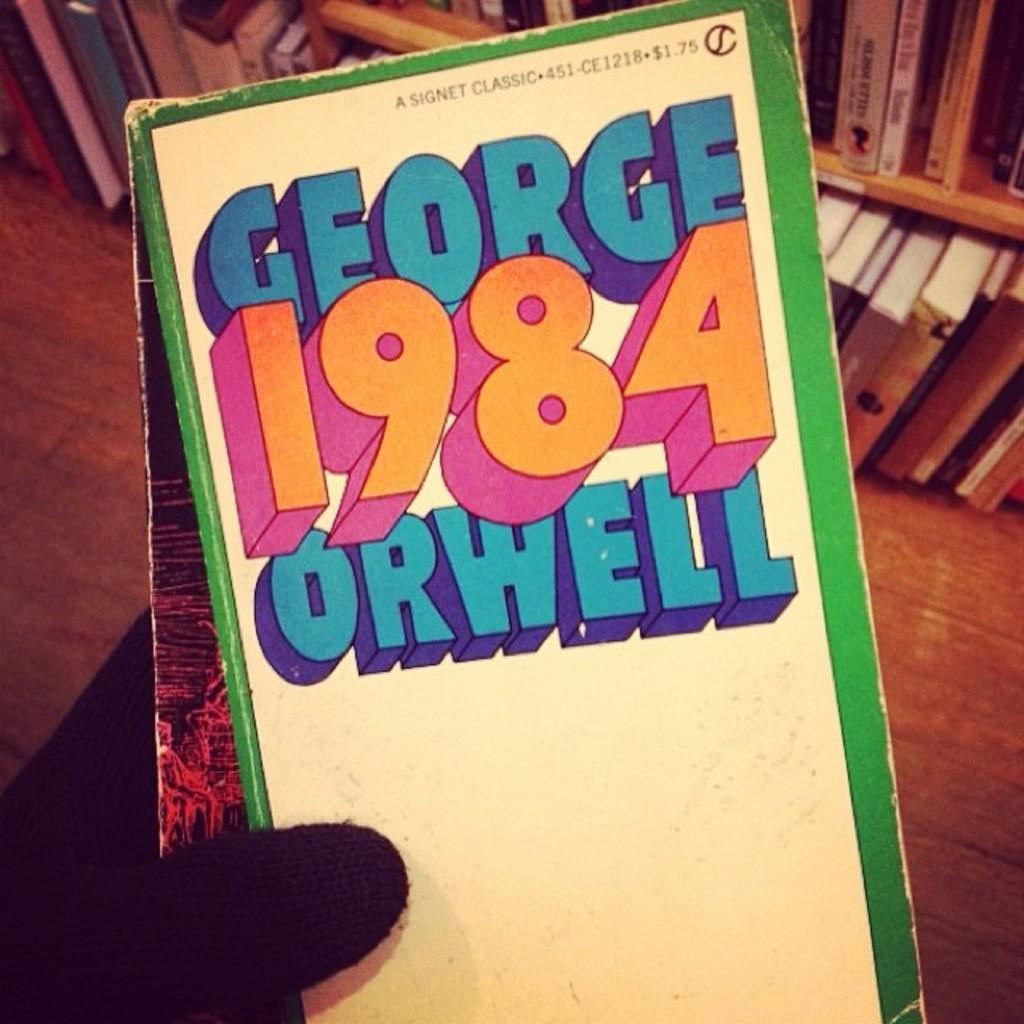Please provide a concise description of this image. In the center of the image we can see one human hand holding one book. On the book, we can see some text. In the background there is a wooden floor, racks, books and a few other objects. 